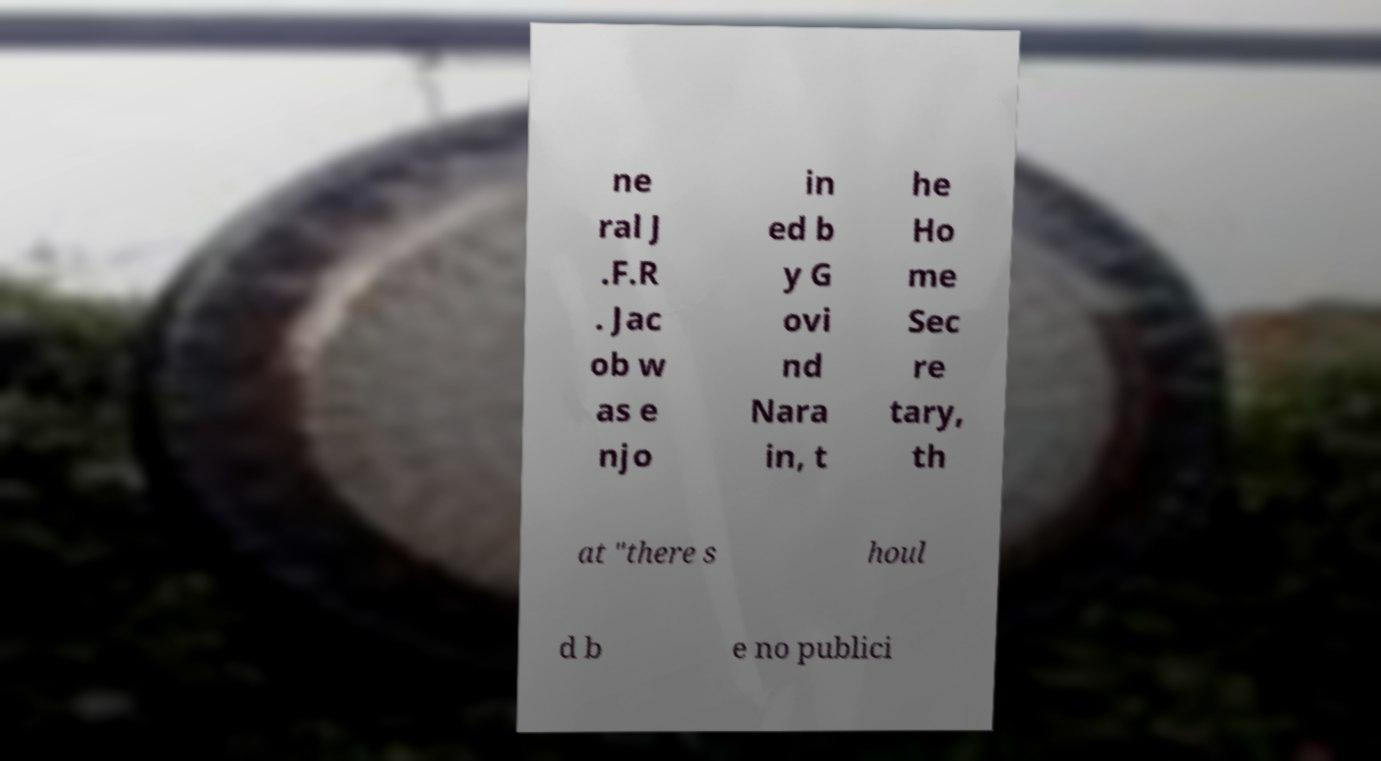Please read and relay the text visible in this image. What does it say? ne ral J .F.R . Jac ob w as e njo in ed b y G ovi nd Nara in, t he Ho me Sec re tary, th at "there s houl d b e no publici 